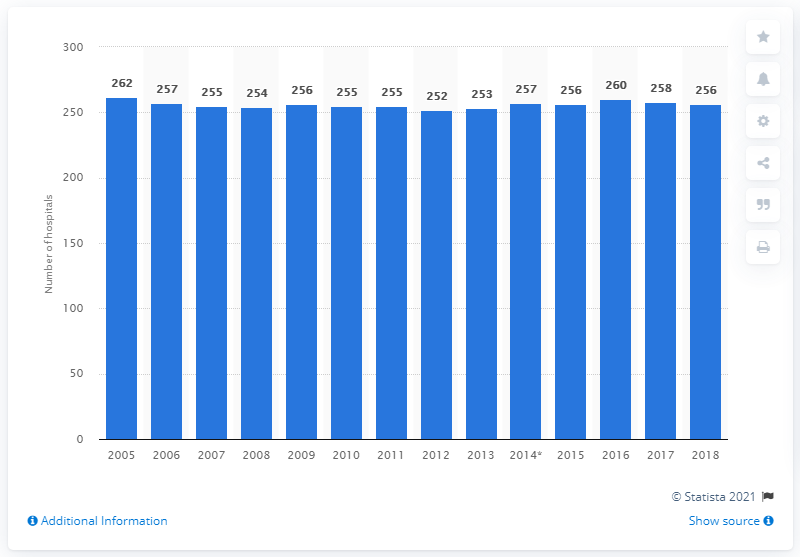Point out several critical features in this image. Since 2005, the number of hospitals in Czechia has remained stable. There were 262 hospitals in the Czech Republic in 2005. 